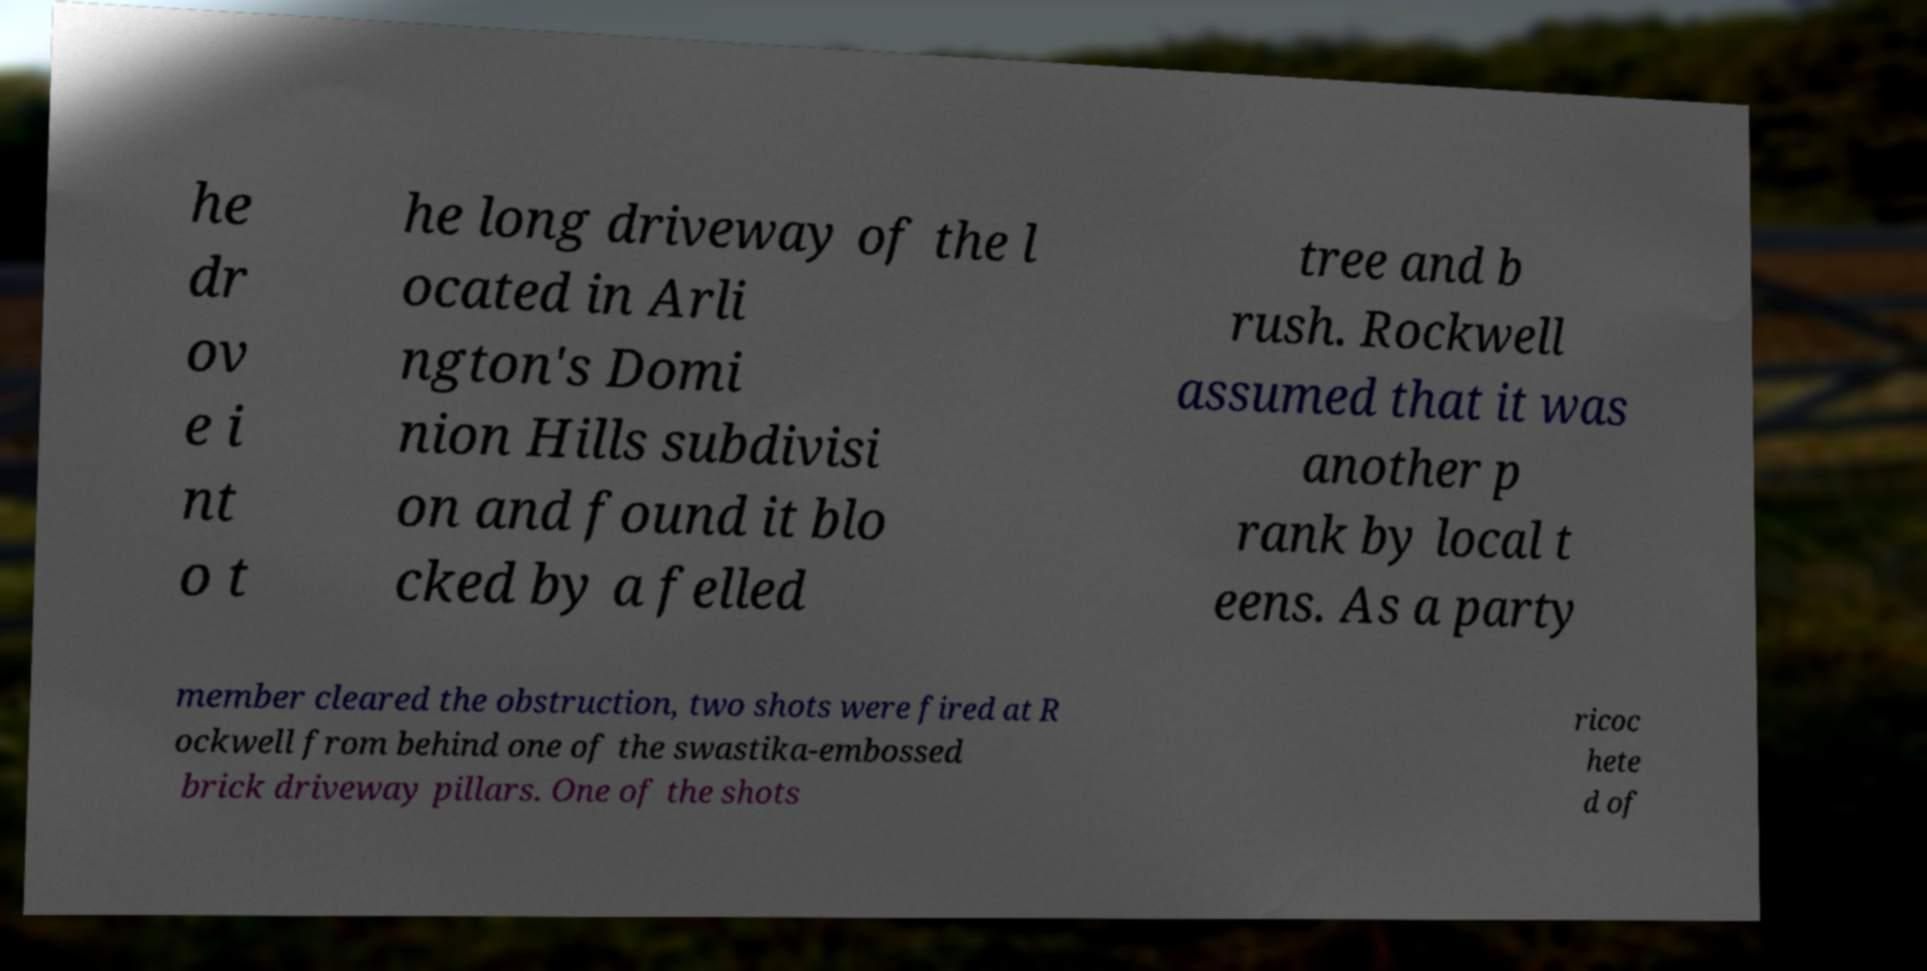Could you assist in decoding the text presented in this image and type it out clearly? he dr ov e i nt o t he long driveway of the l ocated in Arli ngton's Domi nion Hills subdivisi on and found it blo cked by a felled tree and b rush. Rockwell assumed that it was another p rank by local t eens. As a party member cleared the obstruction, two shots were fired at R ockwell from behind one of the swastika-embossed brick driveway pillars. One of the shots ricoc hete d of 